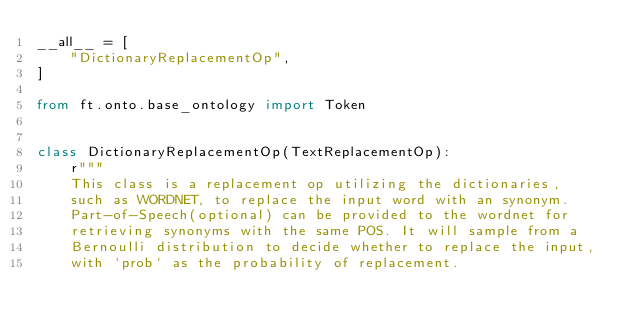Convert code to text. <code><loc_0><loc_0><loc_500><loc_500><_Python_>__all__ = [
    "DictionaryReplacementOp",
]

from ft.onto.base_ontology import Token


class DictionaryReplacementOp(TextReplacementOp):
    r"""
    This class is a replacement op utilizing the dictionaries,
    such as WORDNET, to replace the input word with an synonym.
    Part-of-Speech(optional) can be provided to the wordnet for
    retrieving synonyms with the same POS. It will sample from a
    Bernoulli distribution to decide whether to replace the input,
    with `prob` as the probability of replacement.
</code> 